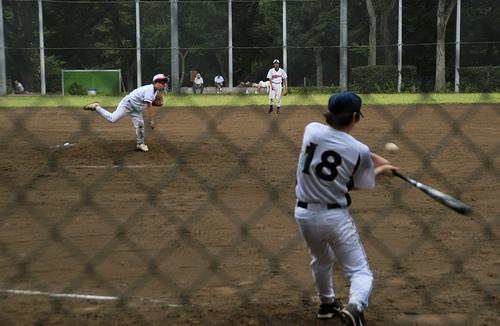How many players can you see?
Give a very brief answer. 3. 